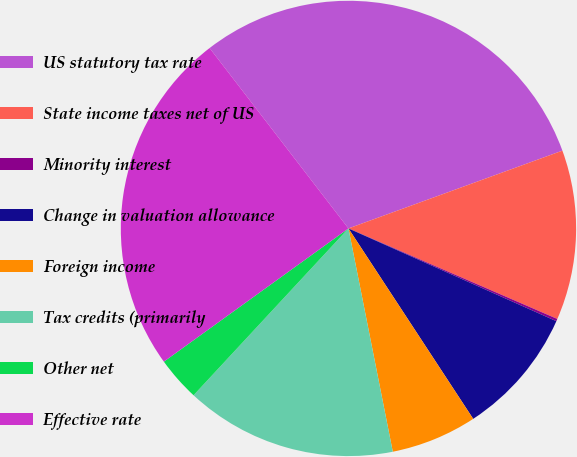<chart> <loc_0><loc_0><loc_500><loc_500><pie_chart><fcel>US statutory tax rate<fcel>State income taxes net of US<fcel>Minority interest<fcel>Change in valuation allowance<fcel>Foreign income<fcel>Tax credits (primarily<fcel>Other net<fcel>Effective rate<nl><fcel>29.89%<fcel>12.06%<fcel>0.17%<fcel>9.09%<fcel>6.11%<fcel>15.03%<fcel>3.14%<fcel>24.51%<nl></chart> 